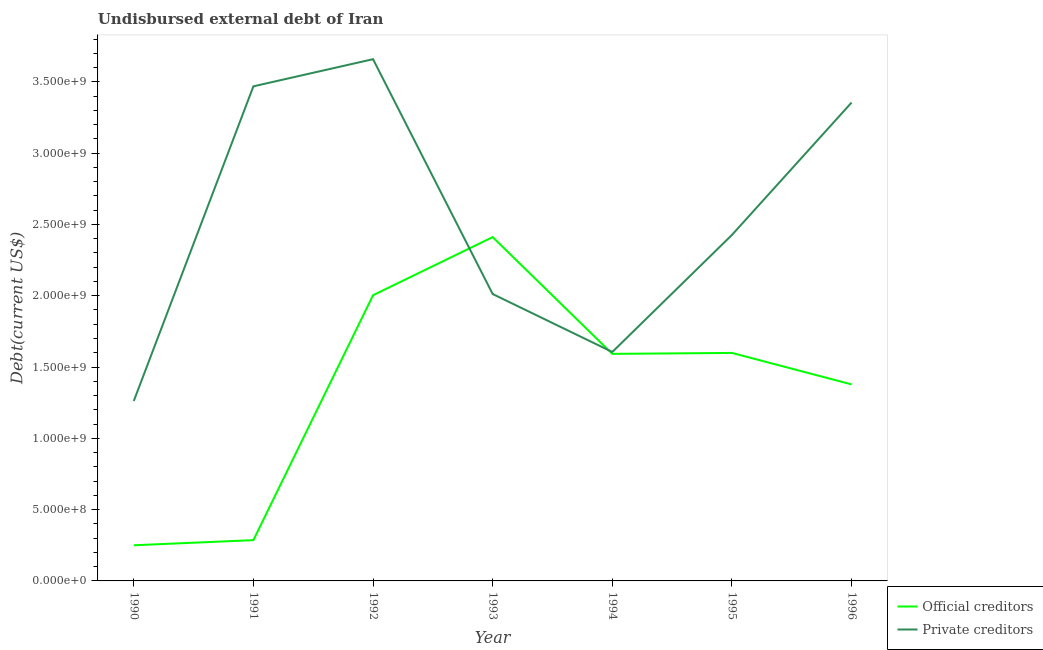How many different coloured lines are there?
Make the answer very short. 2. What is the undisbursed external debt of private creditors in 1991?
Offer a very short reply. 3.47e+09. Across all years, what is the maximum undisbursed external debt of private creditors?
Your answer should be compact. 3.66e+09. Across all years, what is the minimum undisbursed external debt of private creditors?
Make the answer very short. 1.26e+09. In which year was the undisbursed external debt of official creditors minimum?
Offer a terse response. 1990. What is the total undisbursed external debt of private creditors in the graph?
Your response must be concise. 1.78e+1. What is the difference between the undisbursed external debt of private creditors in 1990 and that in 1993?
Give a very brief answer. -7.50e+08. What is the difference between the undisbursed external debt of official creditors in 1994 and the undisbursed external debt of private creditors in 1995?
Your answer should be very brief. -8.34e+08. What is the average undisbursed external debt of official creditors per year?
Your answer should be compact. 1.36e+09. In the year 1991, what is the difference between the undisbursed external debt of private creditors and undisbursed external debt of official creditors?
Your answer should be very brief. 3.18e+09. What is the ratio of the undisbursed external debt of private creditors in 1991 to that in 1995?
Keep it short and to the point. 1.43. Is the difference between the undisbursed external debt of private creditors in 1992 and 1996 greater than the difference between the undisbursed external debt of official creditors in 1992 and 1996?
Offer a terse response. No. What is the difference between the highest and the second highest undisbursed external debt of official creditors?
Your answer should be compact. 4.08e+08. What is the difference between the highest and the lowest undisbursed external debt of private creditors?
Your answer should be very brief. 2.40e+09. In how many years, is the undisbursed external debt of private creditors greater than the average undisbursed external debt of private creditors taken over all years?
Make the answer very short. 3. Does the undisbursed external debt of private creditors monotonically increase over the years?
Offer a very short reply. No. Is the undisbursed external debt of private creditors strictly greater than the undisbursed external debt of official creditors over the years?
Your answer should be very brief. No. How many years are there in the graph?
Ensure brevity in your answer.  7. Does the graph contain grids?
Your response must be concise. No. How many legend labels are there?
Give a very brief answer. 2. How are the legend labels stacked?
Your answer should be very brief. Vertical. What is the title of the graph?
Ensure brevity in your answer.  Undisbursed external debt of Iran. Does "From Government" appear as one of the legend labels in the graph?
Offer a terse response. No. What is the label or title of the X-axis?
Offer a terse response. Year. What is the label or title of the Y-axis?
Ensure brevity in your answer.  Debt(current US$). What is the Debt(current US$) in Official creditors in 1990?
Your response must be concise. 2.50e+08. What is the Debt(current US$) of Private creditors in 1990?
Your answer should be very brief. 1.26e+09. What is the Debt(current US$) of Official creditors in 1991?
Your answer should be very brief. 2.86e+08. What is the Debt(current US$) in Private creditors in 1991?
Offer a very short reply. 3.47e+09. What is the Debt(current US$) of Official creditors in 1992?
Give a very brief answer. 2.00e+09. What is the Debt(current US$) of Private creditors in 1992?
Keep it short and to the point. 3.66e+09. What is the Debt(current US$) in Official creditors in 1993?
Your answer should be very brief. 2.41e+09. What is the Debt(current US$) of Private creditors in 1993?
Provide a succinct answer. 2.01e+09. What is the Debt(current US$) of Official creditors in 1994?
Give a very brief answer. 1.59e+09. What is the Debt(current US$) in Private creditors in 1994?
Give a very brief answer. 1.61e+09. What is the Debt(current US$) in Official creditors in 1995?
Keep it short and to the point. 1.60e+09. What is the Debt(current US$) in Private creditors in 1995?
Your answer should be very brief. 2.43e+09. What is the Debt(current US$) in Official creditors in 1996?
Provide a succinct answer. 1.38e+09. What is the Debt(current US$) in Private creditors in 1996?
Offer a very short reply. 3.35e+09. Across all years, what is the maximum Debt(current US$) in Official creditors?
Keep it short and to the point. 2.41e+09. Across all years, what is the maximum Debt(current US$) in Private creditors?
Keep it short and to the point. 3.66e+09. Across all years, what is the minimum Debt(current US$) in Official creditors?
Your answer should be compact. 2.50e+08. Across all years, what is the minimum Debt(current US$) of Private creditors?
Keep it short and to the point. 1.26e+09. What is the total Debt(current US$) of Official creditors in the graph?
Your answer should be very brief. 9.52e+09. What is the total Debt(current US$) in Private creditors in the graph?
Offer a terse response. 1.78e+1. What is the difference between the Debt(current US$) in Official creditors in 1990 and that in 1991?
Make the answer very short. -3.60e+07. What is the difference between the Debt(current US$) in Private creditors in 1990 and that in 1991?
Give a very brief answer. -2.21e+09. What is the difference between the Debt(current US$) of Official creditors in 1990 and that in 1992?
Make the answer very short. -1.75e+09. What is the difference between the Debt(current US$) of Private creditors in 1990 and that in 1992?
Make the answer very short. -2.40e+09. What is the difference between the Debt(current US$) in Official creditors in 1990 and that in 1993?
Offer a very short reply. -2.16e+09. What is the difference between the Debt(current US$) of Private creditors in 1990 and that in 1993?
Offer a terse response. -7.50e+08. What is the difference between the Debt(current US$) in Official creditors in 1990 and that in 1994?
Ensure brevity in your answer.  -1.34e+09. What is the difference between the Debt(current US$) in Private creditors in 1990 and that in 1994?
Provide a succinct answer. -3.44e+08. What is the difference between the Debt(current US$) of Official creditors in 1990 and that in 1995?
Keep it short and to the point. -1.35e+09. What is the difference between the Debt(current US$) in Private creditors in 1990 and that in 1995?
Offer a very short reply. -1.16e+09. What is the difference between the Debt(current US$) of Official creditors in 1990 and that in 1996?
Offer a terse response. -1.13e+09. What is the difference between the Debt(current US$) of Private creditors in 1990 and that in 1996?
Offer a terse response. -2.09e+09. What is the difference between the Debt(current US$) in Official creditors in 1991 and that in 1992?
Provide a short and direct response. -1.72e+09. What is the difference between the Debt(current US$) in Private creditors in 1991 and that in 1992?
Ensure brevity in your answer.  -1.90e+08. What is the difference between the Debt(current US$) in Official creditors in 1991 and that in 1993?
Provide a short and direct response. -2.13e+09. What is the difference between the Debt(current US$) of Private creditors in 1991 and that in 1993?
Give a very brief answer. 1.46e+09. What is the difference between the Debt(current US$) in Official creditors in 1991 and that in 1994?
Offer a very short reply. -1.31e+09. What is the difference between the Debt(current US$) in Private creditors in 1991 and that in 1994?
Your answer should be very brief. 1.86e+09. What is the difference between the Debt(current US$) in Official creditors in 1991 and that in 1995?
Offer a terse response. -1.31e+09. What is the difference between the Debt(current US$) in Private creditors in 1991 and that in 1995?
Provide a succinct answer. 1.04e+09. What is the difference between the Debt(current US$) in Official creditors in 1991 and that in 1996?
Keep it short and to the point. -1.09e+09. What is the difference between the Debt(current US$) in Private creditors in 1991 and that in 1996?
Provide a succinct answer. 1.14e+08. What is the difference between the Debt(current US$) of Official creditors in 1992 and that in 1993?
Provide a short and direct response. -4.08e+08. What is the difference between the Debt(current US$) in Private creditors in 1992 and that in 1993?
Your answer should be compact. 1.65e+09. What is the difference between the Debt(current US$) in Official creditors in 1992 and that in 1994?
Provide a short and direct response. 4.11e+08. What is the difference between the Debt(current US$) of Private creditors in 1992 and that in 1994?
Your answer should be very brief. 2.05e+09. What is the difference between the Debt(current US$) of Official creditors in 1992 and that in 1995?
Give a very brief answer. 4.05e+08. What is the difference between the Debt(current US$) in Private creditors in 1992 and that in 1995?
Provide a short and direct response. 1.23e+09. What is the difference between the Debt(current US$) in Official creditors in 1992 and that in 1996?
Offer a very short reply. 6.25e+08. What is the difference between the Debt(current US$) of Private creditors in 1992 and that in 1996?
Keep it short and to the point. 3.04e+08. What is the difference between the Debt(current US$) of Official creditors in 1993 and that in 1994?
Your answer should be very brief. 8.19e+08. What is the difference between the Debt(current US$) in Private creditors in 1993 and that in 1994?
Your answer should be very brief. 4.06e+08. What is the difference between the Debt(current US$) of Official creditors in 1993 and that in 1995?
Your response must be concise. 8.12e+08. What is the difference between the Debt(current US$) of Private creditors in 1993 and that in 1995?
Provide a succinct answer. -4.15e+08. What is the difference between the Debt(current US$) in Official creditors in 1993 and that in 1996?
Offer a terse response. 1.03e+09. What is the difference between the Debt(current US$) in Private creditors in 1993 and that in 1996?
Offer a very short reply. -1.34e+09. What is the difference between the Debt(current US$) in Official creditors in 1994 and that in 1995?
Your answer should be compact. -6.68e+06. What is the difference between the Debt(current US$) in Private creditors in 1994 and that in 1995?
Your answer should be compact. -8.21e+08. What is the difference between the Debt(current US$) in Official creditors in 1994 and that in 1996?
Provide a succinct answer. 2.14e+08. What is the difference between the Debt(current US$) in Private creditors in 1994 and that in 1996?
Your response must be concise. -1.75e+09. What is the difference between the Debt(current US$) of Official creditors in 1995 and that in 1996?
Ensure brevity in your answer.  2.21e+08. What is the difference between the Debt(current US$) of Private creditors in 1995 and that in 1996?
Ensure brevity in your answer.  -9.28e+08. What is the difference between the Debt(current US$) in Official creditors in 1990 and the Debt(current US$) in Private creditors in 1991?
Your answer should be very brief. -3.22e+09. What is the difference between the Debt(current US$) in Official creditors in 1990 and the Debt(current US$) in Private creditors in 1992?
Provide a short and direct response. -3.41e+09. What is the difference between the Debt(current US$) of Official creditors in 1990 and the Debt(current US$) of Private creditors in 1993?
Keep it short and to the point. -1.76e+09. What is the difference between the Debt(current US$) in Official creditors in 1990 and the Debt(current US$) in Private creditors in 1994?
Ensure brevity in your answer.  -1.36e+09. What is the difference between the Debt(current US$) in Official creditors in 1990 and the Debt(current US$) in Private creditors in 1995?
Your response must be concise. -2.18e+09. What is the difference between the Debt(current US$) of Official creditors in 1990 and the Debt(current US$) of Private creditors in 1996?
Offer a very short reply. -3.10e+09. What is the difference between the Debt(current US$) in Official creditors in 1991 and the Debt(current US$) in Private creditors in 1992?
Give a very brief answer. -3.37e+09. What is the difference between the Debt(current US$) of Official creditors in 1991 and the Debt(current US$) of Private creditors in 1993?
Offer a very short reply. -1.73e+09. What is the difference between the Debt(current US$) in Official creditors in 1991 and the Debt(current US$) in Private creditors in 1994?
Offer a very short reply. -1.32e+09. What is the difference between the Debt(current US$) of Official creditors in 1991 and the Debt(current US$) of Private creditors in 1995?
Give a very brief answer. -2.14e+09. What is the difference between the Debt(current US$) in Official creditors in 1991 and the Debt(current US$) in Private creditors in 1996?
Ensure brevity in your answer.  -3.07e+09. What is the difference between the Debt(current US$) of Official creditors in 1992 and the Debt(current US$) of Private creditors in 1993?
Provide a short and direct response. -8.50e+06. What is the difference between the Debt(current US$) in Official creditors in 1992 and the Debt(current US$) in Private creditors in 1994?
Offer a very short reply. 3.98e+08. What is the difference between the Debt(current US$) in Official creditors in 1992 and the Debt(current US$) in Private creditors in 1995?
Offer a very short reply. -4.23e+08. What is the difference between the Debt(current US$) in Official creditors in 1992 and the Debt(current US$) in Private creditors in 1996?
Your answer should be compact. -1.35e+09. What is the difference between the Debt(current US$) of Official creditors in 1993 and the Debt(current US$) of Private creditors in 1994?
Your answer should be very brief. 8.06e+08. What is the difference between the Debt(current US$) of Official creditors in 1993 and the Debt(current US$) of Private creditors in 1995?
Your answer should be very brief. -1.54e+07. What is the difference between the Debt(current US$) in Official creditors in 1993 and the Debt(current US$) in Private creditors in 1996?
Offer a very short reply. -9.44e+08. What is the difference between the Debt(current US$) of Official creditors in 1994 and the Debt(current US$) of Private creditors in 1995?
Give a very brief answer. -8.34e+08. What is the difference between the Debt(current US$) in Official creditors in 1994 and the Debt(current US$) in Private creditors in 1996?
Provide a succinct answer. -1.76e+09. What is the difference between the Debt(current US$) in Official creditors in 1995 and the Debt(current US$) in Private creditors in 1996?
Offer a terse response. -1.76e+09. What is the average Debt(current US$) in Official creditors per year?
Provide a short and direct response. 1.36e+09. What is the average Debt(current US$) in Private creditors per year?
Ensure brevity in your answer.  2.54e+09. In the year 1990, what is the difference between the Debt(current US$) in Official creditors and Debt(current US$) in Private creditors?
Offer a terse response. -1.01e+09. In the year 1991, what is the difference between the Debt(current US$) in Official creditors and Debt(current US$) in Private creditors?
Ensure brevity in your answer.  -3.18e+09. In the year 1992, what is the difference between the Debt(current US$) in Official creditors and Debt(current US$) in Private creditors?
Make the answer very short. -1.66e+09. In the year 1993, what is the difference between the Debt(current US$) in Official creditors and Debt(current US$) in Private creditors?
Offer a very short reply. 3.99e+08. In the year 1994, what is the difference between the Debt(current US$) in Official creditors and Debt(current US$) in Private creditors?
Offer a very short reply. -1.33e+07. In the year 1995, what is the difference between the Debt(current US$) of Official creditors and Debt(current US$) of Private creditors?
Ensure brevity in your answer.  -8.28e+08. In the year 1996, what is the difference between the Debt(current US$) in Official creditors and Debt(current US$) in Private creditors?
Your response must be concise. -1.98e+09. What is the ratio of the Debt(current US$) in Official creditors in 1990 to that in 1991?
Your answer should be compact. 0.87. What is the ratio of the Debt(current US$) in Private creditors in 1990 to that in 1991?
Keep it short and to the point. 0.36. What is the ratio of the Debt(current US$) in Official creditors in 1990 to that in 1992?
Provide a short and direct response. 0.12. What is the ratio of the Debt(current US$) in Private creditors in 1990 to that in 1992?
Offer a terse response. 0.34. What is the ratio of the Debt(current US$) of Official creditors in 1990 to that in 1993?
Your answer should be compact. 0.1. What is the ratio of the Debt(current US$) of Private creditors in 1990 to that in 1993?
Provide a short and direct response. 0.63. What is the ratio of the Debt(current US$) in Official creditors in 1990 to that in 1994?
Ensure brevity in your answer.  0.16. What is the ratio of the Debt(current US$) in Private creditors in 1990 to that in 1994?
Make the answer very short. 0.79. What is the ratio of the Debt(current US$) of Official creditors in 1990 to that in 1995?
Ensure brevity in your answer.  0.16. What is the ratio of the Debt(current US$) of Private creditors in 1990 to that in 1995?
Offer a terse response. 0.52. What is the ratio of the Debt(current US$) in Official creditors in 1990 to that in 1996?
Offer a very short reply. 0.18. What is the ratio of the Debt(current US$) of Private creditors in 1990 to that in 1996?
Ensure brevity in your answer.  0.38. What is the ratio of the Debt(current US$) of Official creditors in 1991 to that in 1992?
Your answer should be very brief. 0.14. What is the ratio of the Debt(current US$) of Private creditors in 1991 to that in 1992?
Your answer should be compact. 0.95. What is the ratio of the Debt(current US$) of Official creditors in 1991 to that in 1993?
Give a very brief answer. 0.12. What is the ratio of the Debt(current US$) in Private creditors in 1991 to that in 1993?
Ensure brevity in your answer.  1.72. What is the ratio of the Debt(current US$) of Official creditors in 1991 to that in 1994?
Make the answer very short. 0.18. What is the ratio of the Debt(current US$) in Private creditors in 1991 to that in 1994?
Your answer should be very brief. 2.16. What is the ratio of the Debt(current US$) in Official creditors in 1991 to that in 1995?
Your response must be concise. 0.18. What is the ratio of the Debt(current US$) of Private creditors in 1991 to that in 1995?
Keep it short and to the point. 1.43. What is the ratio of the Debt(current US$) in Official creditors in 1991 to that in 1996?
Make the answer very short. 0.21. What is the ratio of the Debt(current US$) of Private creditors in 1991 to that in 1996?
Give a very brief answer. 1.03. What is the ratio of the Debt(current US$) in Official creditors in 1992 to that in 1993?
Keep it short and to the point. 0.83. What is the ratio of the Debt(current US$) of Private creditors in 1992 to that in 1993?
Provide a succinct answer. 1.82. What is the ratio of the Debt(current US$) of Official creditors in 1992 to that in 1994?
Your answer should be compact. 1.26. What is the ratio of the Debt(current US$) of Private creditors in 1992 to that in 1994?
Offer a very short reply. 2.28. What is the ratio of the Debt(current US$) in Official creditors in 1992 to that in 1995?
Ensure brevity in your answer.  1.25. What is the ratio of the Debt(current US$) of Private creditors in 1992 to that in 1995?
Offer a very short reply. 1.51. What is the ratio of the Debt(current US$) in Official creditors in 1992 to that in 1996?
Make the answer very short. 1.45. What is the ratio of the Debt(current US$) in Private creditors in 1992 to that in 1996?
Keep it short and to the point. 1.09. What is the ratio of the Debt(current US$) in Official creditors in 1993 to that in 1994?
Your response must be concise. 1.51. What is the ratio of the Debt(current US$) of Private creditors in 1993 to that in 1994?
Your answer should be very brief. 1.25. What is the ratio of the Debt(current US$) of Official creditors in 1993 to that in 1995?
Offer a terse response. 1.51. What is the ratio of the Debt(current US$) of Private creditors in 1993 to that in 1995?
Give a very brief answer. 0.83. What is the ratio of the Debt(current US$) in Official creditors in 1993 to that in 1996?
Provide a succinct answer. 1.75. What is the ratio of the Debt(current US$) in Private creditors in 1993 to that in 1996?
Offer a terse response. 0.6. What is the ratio of the Debt(current US$) in Official creditors in 1994 to that in 1995?
Your answer should be very brief. 1. What is the ratio of the Debt(current US$) in Private creditors in 1994 to that in 1995?
Offer a terse response. 0.66. What is the ratio of the Debt(current US$) of Official creditors in 1994 to that in 1996?
Give a very brief answer. 1.16. What is the ratio of the Debt(current US$) of Private creditors in 1994 to that in 1996?
Offer a terse response. 0.48. What is the ratio of the Debt(current US$) of Official creditors in 1995 to that in 1996?
Make the answer very short. 1.16. What is the ratio of the Debt(current US$) of Private creditors in 1995 to that in 1996?
Make the answer very short. 0.72. What is the difference between the highest and the second highest Debt(current US$) in Official creditors?
Keep it short and to the point. 4.08e+08. What is the difference between the highest and the second highest Debt(current US$) in Private creditors?
Your answer should be compact. 1.90e+08. What is the difference between the highest and the lowest Debt(current US$) of Official creditors?
Provide a short and direct response. 2.16e+09. What is the difference between the highest and the lowest Debt(current US$) in Private creditors?
Your answer should be very brief. 2.40e+09. 